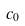<formula> <loc_0><loc_0><loc_500><loc_500>c _ { 0 }</formula> 